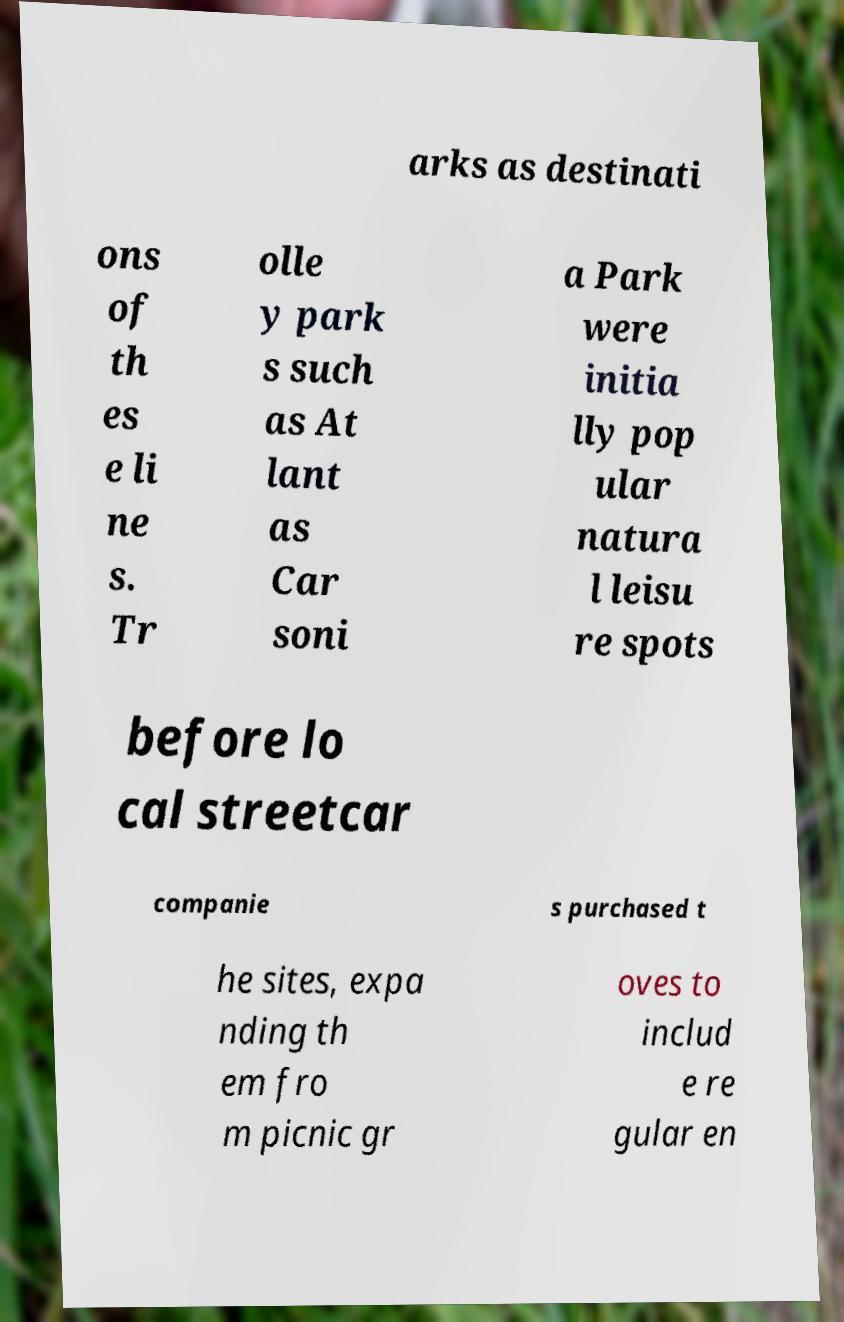Please identify and transcribe the text found in this image. arks as destinati ons of th es e li ne s. Tr olle y park s such as At lant as Car soni a Park were initia lly pop ular natura l leisu re spots before lo cal streetcar companie s purchased t he sites, expa nding th em fro m picnic gr oves to includ e re gular en 